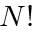Convert formula to latex. <formula><loc_0><loc_0><loc_500><loc_500>N !</formula> 